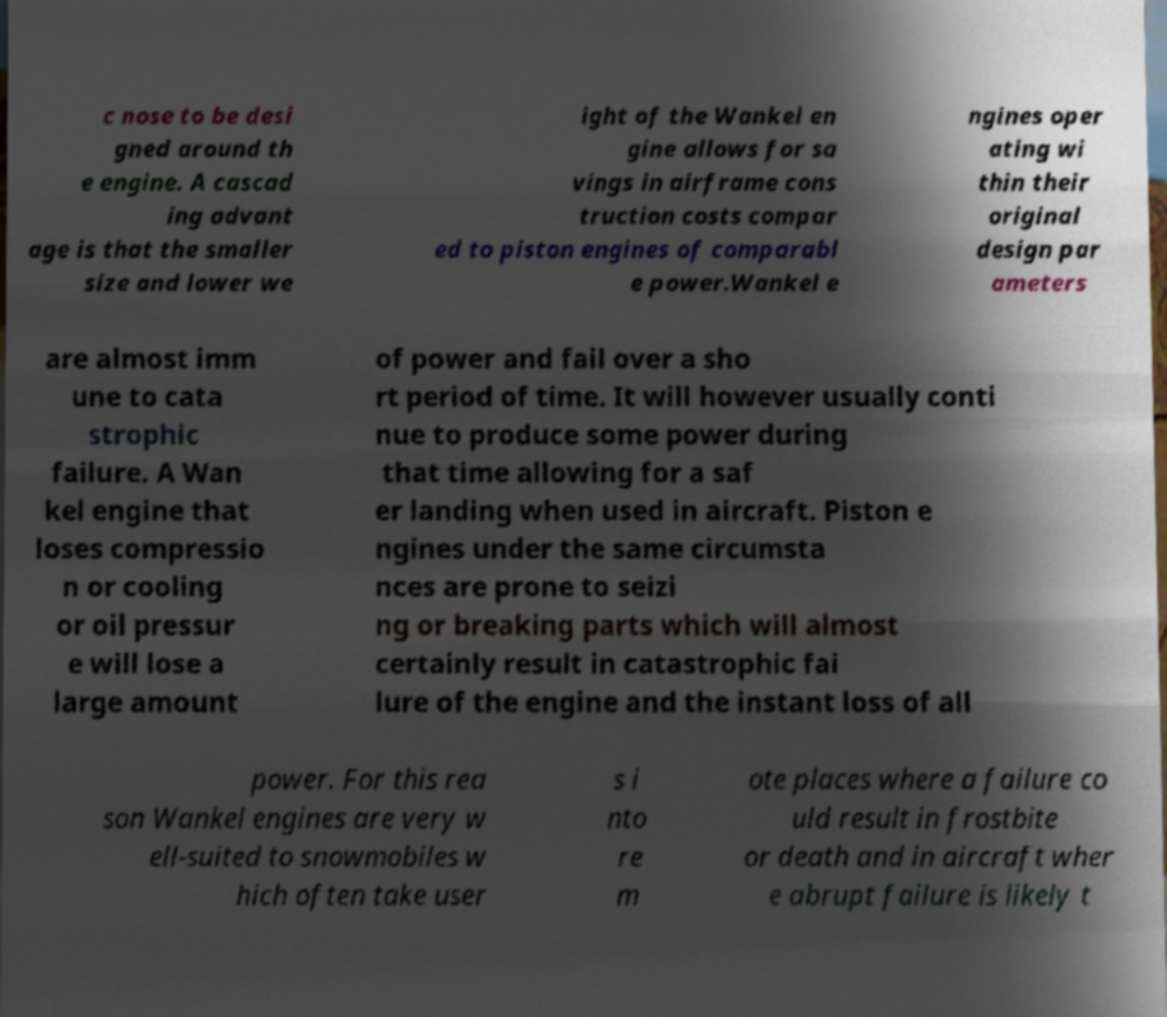For documentation purposes, I need the text within this image transcribed. Could you provide that? c nose to be desi gned around th e engine. A cascad ing advant age is that the smaller size and lower we ight of the Wankel en gine allows for sa vings in airframe cons truction costs compar ed to piston engines of comparabl e power.Wankel e ngines oper ating wi thin their original design par ameters are almost imm une to cata strophic failure. A Wan kel engine that loses compressio n or cooling or oil pressur e will lose a large amount of power and fail over a sho rt period of time. It will however usually conti nue to produce some power during that time allowing for a saf er landing when used in aircraft. Piston e ngines under the same circumsta nces are prone to seizi ng or breaking parts which will almost certainly result in catastrophic fai lure of the engine and the instant loss of all power. For this rea son Wankel engines are very w ell-suited to snowmobiles w hich often take user s i nto re m ote places where a failure co uld result in frostbite or death and in aircraft wher e abrupt failure is likely t 